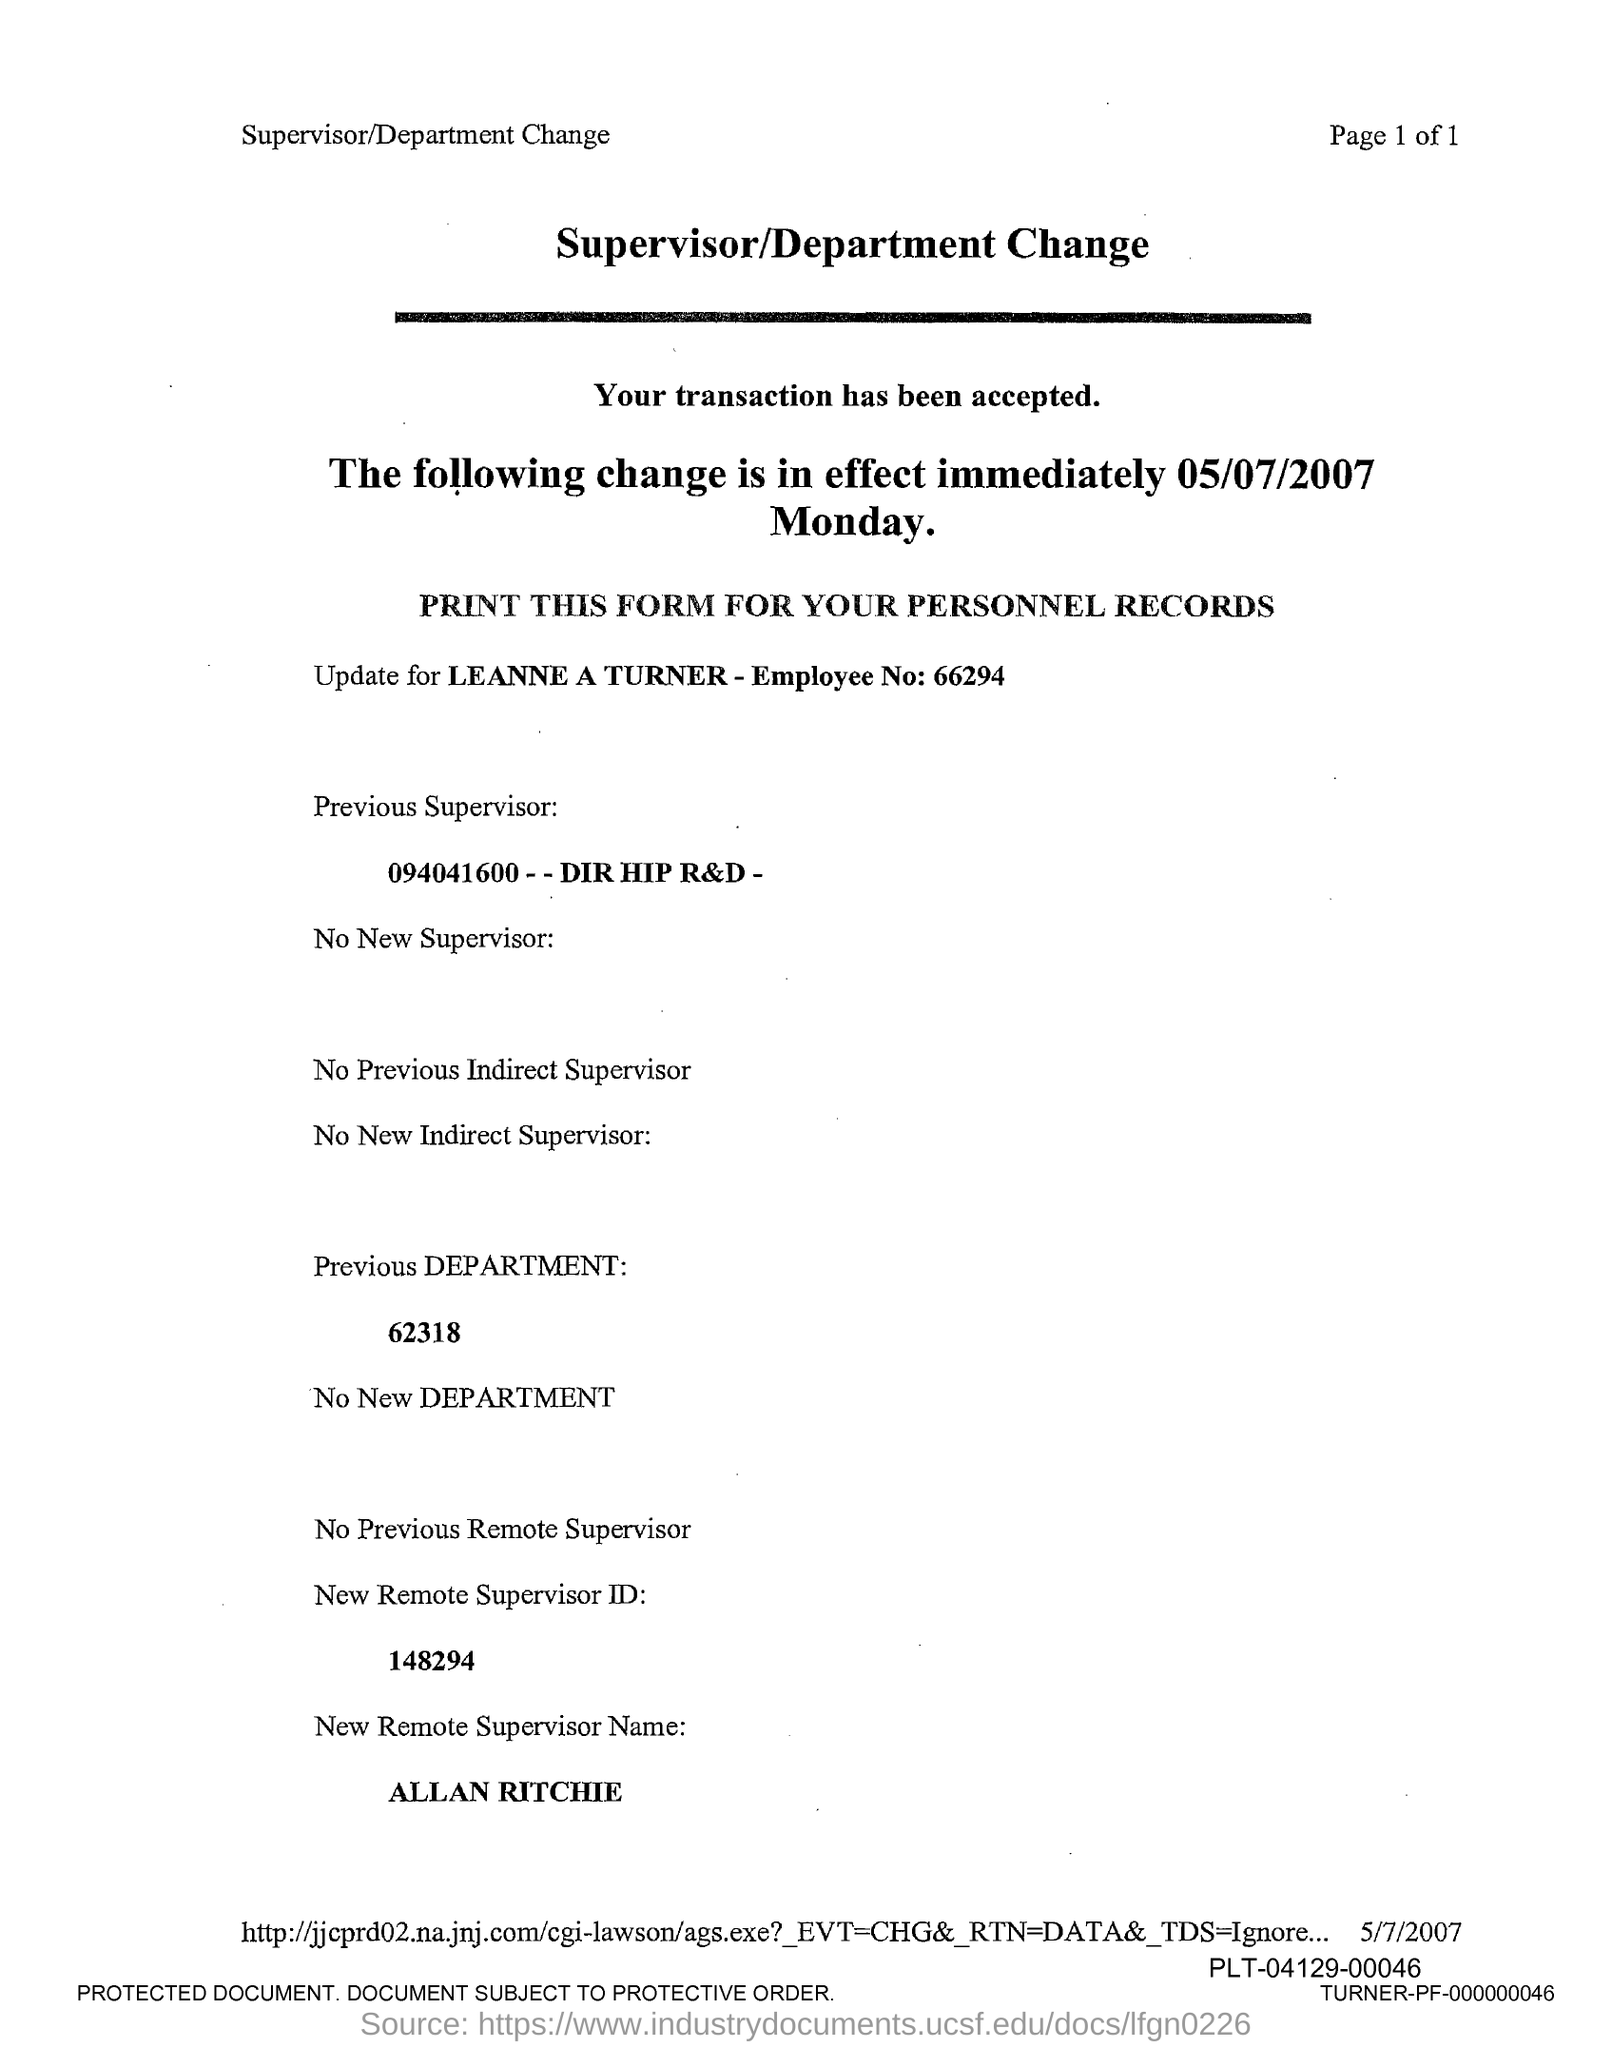Draw attention to some important aspects in this diagram. The new remote supervisor ID is 148294, as specified in the form. What is the previous department number mentioned in the form? 62318...". Leanne Turner's employee number is 66294. The new remote supervisor name mentioned in the form is ALLAN RITCHIE. 